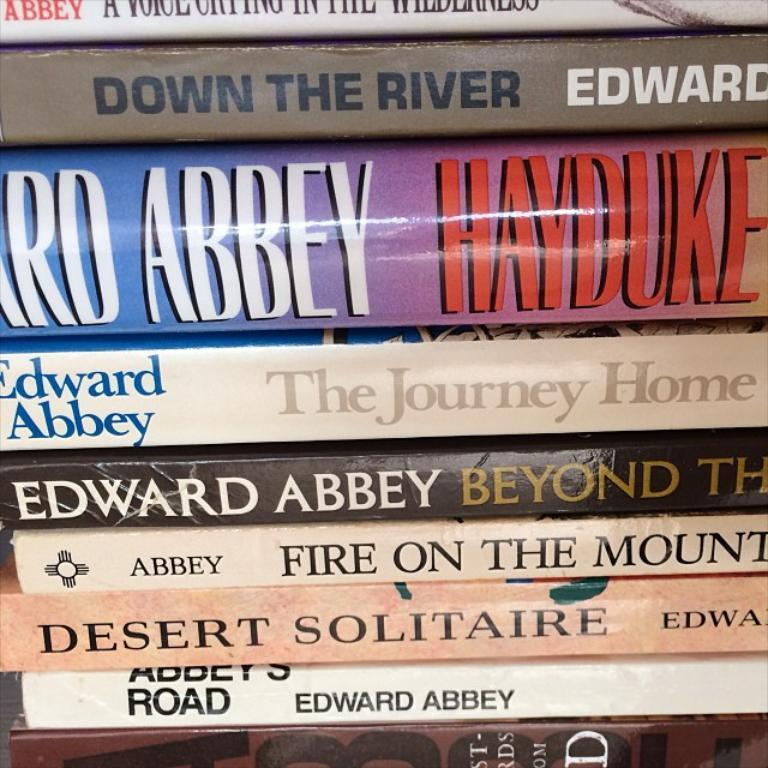<image>
Give a short and clear explanation of the subsequent image. A selection of books together including the title The Journey Home. 